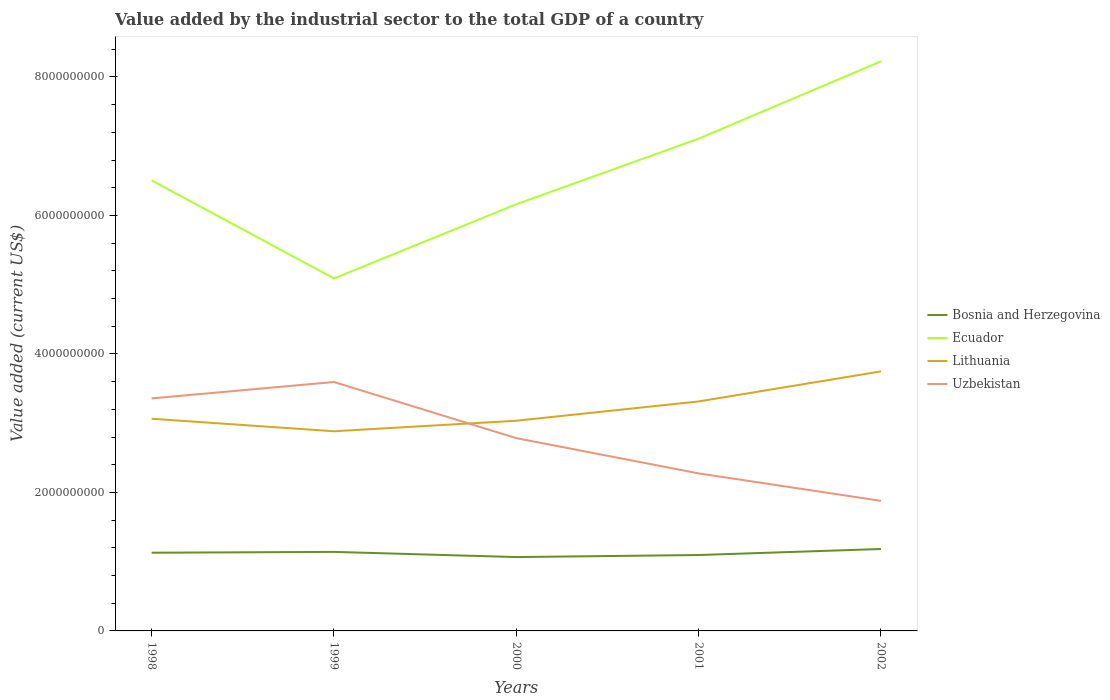How many different coloured lines are there?
Offer a very short reply. 4. Is the number of lines equal to the number of legend labels?
Offer a terse response. Yes. Across all years, what is the maximum value added by the industrial sector to the total GDP in Ecuador?
Keep it short and to the point. 5.09e+09. In which year was the value added by the industrial sector to the total GDP in Ecuador maximum?
Provide a short and direct response. 1999. What is the total value added by the industrial sector to the total GDP in Ecuador in the graph?
Provide a short and direct response. -6.03e+08. What is the difference between the highest and the second highest value added by the industrial sector to the total GDP in Lithuania?
Provide a succinct answer. 8.65e+08. Is the value added by the industrial sector to the total GDP in Lithuania strictly greater than the value added by the industrial sector to the total GDP in Ecuador over the years?
Offer a very short reply. Yes. How many lines are there?
Provide a succinct answer. 4. How many years are there in the graph?
Your answer should be compact. 5. What is the difference between two consecutive major ticks on the Y-axis?
Your answer should be very brief. 2.00e+09. Does the graph contain grids?
Give a very brief answer. No. What is the title of the graph?
Your answer should be very brief. Value added by the industrial sector to the total GDP of a country. What is the label or title of the Y-axis?
Give a very brief answer. Value added (current US$). What is the Value added (current US$) of Bosnia and Herzegovina in 1998?
Provide a short and direct response. 1.13e+09. What is the Value added (current US$) of Ecuador in 1998?
Provide a succinct answer. 6.51e+09. What is the Value added (current US$) in Lithuania in 1998?
Offer a terse response. 3.06e+09. What is the Value added (current US$) in Uzbekistan in 1998?
Offer a very short reply. 3.36e+09. What is the Value added (current US$) in Bosnia and Herzegovina in 1999?
Make the answer very short. 1.14e+09. What is the Value added (current US$) in Ecuador in 1999?
Provide a short and direct response. 5.09e+09. What is the Value added (current US$) in Lithuania in 1999?
Your response must be concise. 2.88e+09. What is the Value added (current US$) in Uzbekistan in 1999?
Keep it short and to the point. 3.59e+09. What is the Value added (current US$) in Bosnia and Herzegovina in 2000?
Your answer should be very brief. 1.07e+09. What is the Value added (current US$) in Ecuador in 2000?
Provide a short and direct response. 6.16e+09. What is the Value added (current US$) in Lithuania in 2000?
Ensure brevity in your answer.  3.04e+09. What is the Value added (current US$) of Uzbekistan in 2000?
Your answer should be very brief. 2.78e+09. What is the Value added (current US$) in Bosnia and Herzegovina in 2001?
Your answer should be very brief. 1.10e+09. What is the Value added (current US$) of Ecuador in 2001?
Offer a terse response. 7.11e+09. What is the Value added (current US$) of Lithuania in 2001?
Ensure brevity in your answer.  3.31e+09. What is the Value added (current US$) in Uzbekistan in 2001?
Give a very brief answer. 2.27e+09. What is the Value added (current US$) of Bosnia and Herzegovina in 2002?
Ensure brevity in your answer.  1.18e+09. What is the Value added (current US$) of Ecuador in 2002?
Provide a short and direct response. 8.22e+09. What is the Value added (current US$) in Lithuania in 2002?
Provide a short and direct response. 3.75e+09. What is the Value added (current US$) of Uzbekistan in 2002?
Make the answer very short. 1.88e+09. Across all years, what is the maximum Value added (current US$) of Bosnia and Herzegovina?
Give a very brief answer. 1.18e+09. Across all years, what is the maximum Value added (current US$) of Ecuador?
Your answer should be very brief. 8.22e+09. Across all years, what is the maximum Value added (current US$) in Lithuania?
Your answer should be compact. 3.75e+09. Across all years, what is the maximum Value added (current US$) of Uzbekistan?
Give a very brief answer. 3.59e+09. Across all years, what is the minimum Value added (current US$) of Bosnia and Herzegovina?
Your response must be concise. 1.07e+09. Across all years, what is the minimum Value added (current US$) of Ecuador?
Offer a very short reply. 5.09e+09. Across all years, what is the minimum Value added (current US$) of Lithuania?
Your answer should be very brief. 2.88e+09. Across all years, what is the minimum Value added (current US$) in Uzbekistan?
Provide a short and direct response. 1.88e+09. What is the total Value added (current US$) in Bosnia and Herzegovina in the graph?
Give a very brief answer. 5.62e+09. What is the total Value added (current US$) in Ecuador in the graph?
Provide a short and direct response. 3.31e+1. What is the total Value added (current US$) in Lithuania in the graph?
Ensure brevity in your answer.  1.60e+1. What is the total Value added (current US$) of Uzbekistan in the graph?
Give a very brief answer. 1.39e+1. What is the difference between the Value added (current US$) of Bosnia and Herzegovina in 1998 and that in 1999?
Your response must be concise. -1.21e+07. What is the difference between the Value added (current US$) in Ecuador in 1998 and that in 1999?
Your response must be concise. 1.42e+09. What is the difference between the Value added (current US$) of Lithuania in 1998 and that in 1999?
Your answer should be compact. 1.81e+08. What is the difference between the Value added (current US$) of Uzbekistan in 1998 and that in 1999?
Provide a short and direct response. -2.37e+08. What is the difference between the Value added (current US$) in Bosnia and Herzegovina in 1998 and that in 2000?
Provide a succinct answer. 6.27e+07. What is the difference between the Value added (current US$) of Ecuador in 1998 and that in 2000?
Offer a terse response. 3.44e+08. What is the difference between the Value added (current US$) of Lithuania in 1998 and that in 2000?
Provide a short and direct response. 2.88e+07. What is the difference between the Value added (current US$) in Uzbekistan in 1998 and that in 2000?
Offer a very short reply. 5.74e+08. What is the difference between the Value added (current US$) of Bosnia and Herzegovina in 1998 and that in 2001?
Offer a terse response. 3.31e+07. What is the difference between the Value added (current US$) of Ecuador in 1998 and that in 2001?
Your answer should be very brief. -6.03e+08. What is the difference between the Value added (current US$) of Lithuania in 1998 and that in 2001?
Provide a short and direct response. -2.49e+08. What is the difference between the Value added (current US$) of Uzbekistan in 1998 and that in 2001?
Offer a very short reply. 1.08e+09. What is the difference between the Value added (current US$) of Bosnia and Herzegovina in 1998 and that in 2002?
Your answer should be very brief. -5.34e+07. What is the difference between the Value added (current US$) of Ecuador in 1998 and that in 2002?
Your answer should be very brief. -1.72e+09. What is the difference between the Value added (current US$) of Lithuania in 1998 and that in 2002?
Keep it short and to the point. -6.84e+08. What is the difference between the Value added (current US$) of Uzbekistan in 1998 and that in 2002?
Your answer should be compact. 1.48e+09. What is the difference between the Value added (current US$) of Bosnia and Herzegovina in 1999 and that in 2000?
Offer a terse response. 7.48e+07. What is the difference between the Value added (current US$) in Ecuador in 1999 and that in 2000?
Your answer should be very brief. -1.07e+09. What is the difference between the Value added (current US$) of Lithuania in 1999 and that in 2000?
Your answer should be very brief. -1.52e+08. What is the difference between the Value added (current US$) of Uzbekistan in 1999 and that in 2000?
Ensure brevity in your answer.  8.11e+08. What is the difference between the Value added (current US$) of Bosnia and Herzegovina in 1999 and that in 2001?
Ensure brevity in your answer.  4.52e+07. What is the difference between the Value added (current US$) in Ecuador in 1999 and that in 2001?
Make the answer very short. -2.02e+09. What is the difference between the Value added (current US$) of Lithuania in 1999 and that in 2001?
Ensure brevity in your answer.  -4.30e+08. What is the difference between the Value added (current US$) of Uzbekistan in 1999 and that in 2001?
Offer a very short reply. 1.32e+09. What is the difference between the Value added (current US$) in Bosnia and Herzegovina in 1999 and that in 2002?
Keep it short and to the point. -4.13e+07. What is the difference between the Value added (current US$) of Ecuador in 1999 and that in 2002?
Ensure brevity in your answer.  -3.13e+09. What is the difference between the Value added (current US$) in Lithuania in 1999 and that in 2002?
Provide a succinct answer. -8.65e+08. What is the difference between the Value added (current US$) of Uzbekistan in 1999 and that in 2002?
Make the answer very short. 1.72e+09. What is the difference between the Value added (current US$) in Bosnia and Herzegovina in 2000 and that in 2001?
Keep it short and to the point. -2.96e+07. What is the difference between the Value added (current US$) in Ecuador in 2000 and that in 2001?
Provide a short and direct response. -9.47e+08. What is the difference between the Value added (current US$) of Lithuania in 2000 and that in 2001?
Ensure brevity in your answer.  -2.78e+08. What is the difference between the Value added (current US$) of Uzbekistan in 2000 and that in 2001?
Ensure brevity in your answer.  5.09e+08. What is the difference between the Value added (current US$) in Bosnia and Herzegovina in 2000 and that in 2002?
Provide a short and direct response. -1.16e+08. What is the difference between the Value added (current US$) of Ecuador in 2000 and that in 2002?
Your answer should be compact. -2.06e+09. What is the difference between the Value added (current US$) of Lithuania in 2000 and that in 2002?
Your answer should be very brief. -7.13e+08. What is the difference between the Value added (current US$) in Uzbekistan in 2000 and that in 2002?
Your answer should be very brief. 9.05e+08. What is the difference between the Value added (current US$) of Bosnia and Herzegovina in 2001 and that in 2002?
Offer a very short reply. -8.65e+07. What is the difference between the Value added (current US$) of Ecuador in 2001 and that in 2002?
Your answer should be very brief. -1.12e+09. What is the difference between the Value added (current US$) in Lithuania in 2001 and that in 2002?
Offer a terse response. -4.34e+08. What is the difference between the Value added (current US$) in Uzbekistan in 2001 and that in 2002?
Make the answer very short. 3.97e+08. What is the difference between the Value added (current US$) in Bosnia and Herzegovina in 1998 and the Value added (current US$) in Ecuador in 1999?
Keep it short and to the point. -3.96e+09. What is the difference between the Value added (current US$) of Bosnia and Herzegovina in 1998 and the Value added (current US$) of Lithuania in 1999?
Your response must be concise. -1.75e+09. What is the difference between the Value added (current US$) of Bosnia and Herzegovina in 1998 and the Value added (current US$) of Uzbekistan in 1999?
Your answer should be compact. -2.47e+09. What is the difference between the Value added (current US$) of Ecuador in 1998 and the Value added (current US$) of Lithuania in 1999?
Offer a very short reply. 3.62e+09. What is the difference between the Value added (current US$) of Ecuador in 1998 and the Value added (current US$) of Uzbekistan in 1999?
Provide a succinct answer. 2.91e+09. What is the difference between the Value added (current US$) in Lithuania in 1998 and the Value added (current US$) in Uzbekistan in 1999?
Offer a terse response. -5.30e+08. What is the difference between the Value added (current US$) in Bosnia and Herzegovina in 1998 and the Value added (current US$) in Ecuador in 2000?
Your answer should be very brief. -5.03e+09. What is the difference between the Value added (current US$) in Bosnia and Herzegovina in 1998 and the Value added (current US$) in Lithuania in 2000?
Keep it short and to the point. -1.91e+09. What is the difference between the Value added (current US$) in Bosnia and Herzegovina in 1998 and the Value added (current US$) in Uzbekistan in 2000?
Provide a short and direct response. -1.65e+09. What is the difference between the Value added (current US$) in Ecuador in 1998 and the Value added (current US$) in Lithuania in 2000?
Offer a very short reply. 3.47e+09. What is the difference between the Value added (current US$) of Ecuador in 1998 and the Value added (current US$) of Uzbekistan in 2000?
Offer a terse response. 3.72e+09. What is the difference between the Value added (current US$) in Lithuania in 1998 and the Value added (current US$) in Uzbekistan in 2000?
Your answer should be compact. 2.80e+08. What is the difference between the Value added (current US$) in Bosnia and Herzegovina in 1998 and the Value added (current US$) in Ecuador in 2001?
Provide a succinct answer. -5.98e+09. What is the difference between the Value added (current US$) of Bosnia and Herzegovina in 1998 and the Value added (current US$) of Lithuania in 2001?
Offer a terse response. -2.18e+09. What is the difference between the Value added (current US$) of Bosnia and Herzegovina in 1998 and the Value added (current US$) of Uzbekistan in 2001?
Give a very brief answer. -1.15e+09. What is the difference between the Value added (current US$) of Ecuador in 1998 and the Value added (current US$) of Lithuania in 2001?
Give a very brief answer. 3.19e+09. What is the difference between the Value added (current US$) of Ecuador in 1998 and the Value added (current US$) of Uzbekistan in 2001?
Your response must be concise. 4.23e+09. What is the difference between the Value added (current US$) of Lithuania in 1998 and the Value added (current US$) of Uzbekistan in 2001?
Your response must be concise. 7.89e+08. What is the difference between the Value added (current US$) in Bosnia and Herzegovina in 1998 and the Value added (current US$) in Ecuador in 2002?
Your answer should be compact. -7.10e+09. What is the difference between the Value added (current US$) in Bosnia and Herzegovina in 1998 and the Value added (current US$) in Lithuania in 2002?
Your response must be concise. -2.62e+09. What is the difference between the Value added (current US$) of Bosnia and Herzegovina in 1998 and the Value added (current US$) of Uzbekistan in 2002?
Keep it short and to the point. -7.49e+08. What is the difference between the Value added (current US$) of Ecuador in 1998 and the Value added (current US$) of Lithuania in 2002?
Give a very brief answer. 2.76e+09. What is the difference between the Value added (current US$) of Ecuador in 1998 and the Value added (current US$) of Uzbekistan in 2002?
Offer a very short reply. 4.63e+09. What is the difference between the Value added (current US$) in Lithuania in 1998 and the Value added (current US$) in Uzbekistan in 2002?
Your response must be concise. 1.19e+09. What is the difference between the Value added (current US$) of Bosnia and Herzegovina in 1999 and the Value added (current US$) of Ecuador in 2000?
Your response must be concise. -5.02e+09. What is the difference between the Value added (current US$) of Bosnia and Herzegovina in 1999 and the Value added (current US$) of Lithuania in 2000?
Offer a terse response. -1.89e+09. What is the difference between the Value added (current US$) in Bosnia and Herzegovina in 1999 and the Value added (current US$) in Uzbekistan in 2000?
Your answer should be compact. -1.64e+09. What is the difference between the Value added (current US$) in Ecuador in 1999 and the Value added (current US$) in Lithuania in 2000?
Give a very brief answer. 2.05e+09. What is the difference between the Value added (current US$) of Ecuador in 1999 and the Value added (current US$) of Uzbekistan in 2000?
Provide a succinct answer. 2.31e+09. What is the difference between the Value added (current US$) in Lithuania in 1999 and the Value added (current US$) in Uzbekistan in 2000?
Your answer should be compact. 9.94e+07. What is the difference between the Value added (current US$) in Bosnia and Herzegovina in 1999 and the Value added (current US$) in Ecuador in 2001?
Your answer should be compact. -5.97e+09. What is the difference between the Value added (current US$) of Bosnia and Herzegovina in 1999 and the Value added (current US$) of Lithuania in 2001?
Your answer should be very brief. -2.17e+09. What is the difference between the Value added (current US$) in Bosnia and Herzegovina in 1999 and the Value added (current US$) in Uzbekistan in 2001?
Ensure brevity in your answer.  -1.13e+09. What is the difference between the Value added (current US$) of Ecuador in 1999 and the Value added (current US$) of Lithuania in 2001?
Give a very brief answer. 1.78e+09. What is the difference between the Value added (current US$) in Ecuador in 1999 and the Value added (current US$) in Uzbekistan in 2001?
Provide a succinct answer. 2.81e+09. What is the difference between the Value added (current US$) in Lithuania in 1999 and the Value added (current US$) in Uzbekistan in 2001?
Your answer should be compact. 6.08e+08. What is the difference between the Value added (current US$) in Bosnia and Herzegovina in 1999 and the Value added (current US$) in Ecuador in 2002?
Keep it short and to the point. -7.08e+09. What is the difference between the Value added (current US$) in Bosnia and Herzegovina in 1999 and the Value added (current US$) in Lithuania in 2002?
Make the answer very short. -2.61e+09. What is the difference between the Value added (current US$) in Bosnia and Herzegovina in 1999 and the Value added (current US$) in Uzbekistan in 2002?
Your response must be concise. -7.37e+08. What is the difference between the Value added (current US$) of Ecuador in 1999 and the Value added (current US$) of Lithuania in 2002?
Your response must be concise. 1.34e+09. What is the difference between the Value added (current US$) of Ecuador in 1999 and the Value added (current US$) of Uzbekistan in 2002?
Make the answer very short. 3.21e+09. What is the difference between the Value added (current US$) in Lithuania in 1999 and the Value added (current US$) in Uzbekistan in 2002?
Give a very brief answer. 1.00e+09. What is the difference between the Value added (current US$) in Bosnia and Herzegovina in 2000 and the Value added (current US$) in Ecuador in 2001?
Keep it short and to the point. -6.04e+09. What is the difference between the Value added (current US$) of Bosnia and Herzegovina in 2000 and the Value added (current US$) of Lithuania in 2001?
Offer a terse response. -2.25e+09. What is the difference between the Value added (current US$) of Bosnia and Herzegovina in 2000 and the Value added (current US$) of Uzbekistan in 2001?
Provide a short and direct response. -1.21e+09. What is the difference between the Value added (current US$) of Ecuador in 2000 and the Value added (current US$) of Lithuania in 2001?
Ensure brevity in your answer.  2.85e+09. What is the difference between the Value added (current US$) of Ecuador in 2000 and the Value added (current US$) of Uzbekistan in 2001?
Your response must be concise. 3.89e+09. What is the difference between the Value added (current US$) in Lithuania in 2000 and the Value added (current US$) in Uzbekistan in 2001?
Offer a very short reply. 7.60e+08. What is the difference between the Value added (current US$) in Bosnia and Herzegovina in 2000 and the Value added (current US$) in Ecuador in 2002?
Provide a short and direct response. -7.16e+09. What is the difference between the Value added (current US$) of Bosnia and Herzegovina in 2000 and the Value added (current US$) of Lithuania in 2002?
Ensure brevity in your answer.  -2.68e+09. What is the difference between the Value added (current US$) in Bosnia and Herzegovina in 2000 and the Value added (current US$) in Uzbekistan in 2002?
Your answer should be very brief. -8.12e+08. What is the difference between the Value added (current US$) of Ecuador in 2000 and the Value added (current US$) of Lithuania in 2002?
Your answer should be compact. 2.41e+09. What is the difference between the Value added (current US$) in Ecuador in 2000 and the Value added (current US$) in Uzbekistan in 2002?
Ensure brevity in your answer.  4.28e+09. What is the difference between the Value added (current US$) of Lithuania in 2000 and the Value added (current US$) of Uzbekistan in 2002?
Give a very brief answer. 1.16e+09. What is the difference between the Value added (current US$) of Bosnia and Herzegovina in 2001 and the Value added (current US$) of Ecuador in 2002?
Keep it short and to the point. -7.13e+09. What is the difference between the Value added (current US$) of Bosnia and Herzegovina in 2001 and the Value added (current US$) of Lithuania in 2002?
Provide a succinct answer. -2.65e+09. What is the difference between the Value added (current US$) in Bosnia and Herzegovina in 2001 and the Value added (current US$) in Uzbekistan in 2002?
Provide a succinct answer. -7.82e+08. What is the difference between the Value added (current US$) of Ecuador in 2001 and the Value added (current US$) of Lithuania in 2002?
Your answer should be very brief. 3.36e+09. What is the difference between the Value added (current US$) in Ecuador in 2001 and the Value added (current US$) in Uzbekistan in 2002?
Give a very brief answer. 5.23e+09. What is the difference between the Value added (current US$) of Lithuania in 2001 and the Value added (current US$) of Uzbekistan in 2002?
Provide a short and direct response. 1.44e+09. What is the average Value added (current US$) in Bosnia and Herzegovina per year?
Keep it short and to the point. 1.12e+09. What is the average Value added (current US$) in Ecuador per year?
Provide a short and direct response. 6.62e+09. What is the average Value added (current US$) in Lithuania per year?
Your response must be concise. 3.21e+09. What is the average Value added (current US$) of Uzbekistan per year?
Your answer should be compact. 2.78e+09. In the year 1998, what is the difference between the Value added (current US$) in Bosnia and Herzegovina and Value added (current US$) in Ecuador?
Offer a very short reply. -5.38e+09. In the year 1998, what is the difference between the Value added (current US$) in Bosnia and Herzegovina and Value added (current US$) in Lithuania?
Keep it short and to the point. -1.93e+09. In the year 1998, what is the difference between the Value added (current US$) in Bosnia and Herzegovina and Value added (current US$) in Uzbekistan?
Ensure brevity in your answer.  -2.23e+09. In the year 1998, what is the difference between the Value added (current US$) of Ecuador and Value added (current US$) of Lithuania?
Offer a terse response. 3.44e+09. In the year 1998, what is the difference between the Value added (current US$) of Ecuador and Value added (current US$) of Uzbekistan?
Make the answer very short. 3.15e+09. In the year 1998, what is the difference between the Value added (current US$) in Lithuania and Value added (current US$) in Uzbekistan?
Your response must be concise. -2.94e+08. In the year 1999, what is the difference between the Value added (current US$) in Bosnia and Herzegovina and Value added (current US$) in Ecuador?
Keep it short and to the point. -3.95e+09. In the year 1999, what is the difference between the Value added (current US$) of Bosnia and Herzegovina and Value added (current US$) of Lithuania?
Offer a terse response. -1.74e+09. In the year 1999, what is the difference between the Value added (current US$) in Bosnia and Herzegovina and Value added (current US$) in Uzbekistan?
Keep it short and to the point. -2.45e+09. In the year 1999, what is the difference between the Value added (current US$) of Ecuador and Value added (current US$) of Lithuania?
Give a very brief answer. 2.21e+09. In the year 1999, what is the difference between the Value added (current US$) in Ecuador and Value added (current US$) in Uzbekistan?
Keep it short and to the point. 1.50e+09. In the year 1999, what is the difference between the Value added (current US$) in Lithuania and Value added (current US$) in Uzbekistan?
Provide a short and direct response. -7.11e+08. In the year 2000, what is the difference between the Value added (current US$) of Bosnia and Herzegovina and Value added (current US$) of Ecuador?
Your answer should be very brief. -5.09e+09. In the year 2000, what is the difference between the Value added (current US$) of Bosnia and Herzegovina and Value added (current US$) of Lithuania?
Ensure brevity in your answer.  -1.97e+09. In the year 2000, what is the difference between the Value added (current US$) in Bosnia and Herzegovina and Value added (current US$) in Uzbekistan?
Provide a succinct answer. -1.72e+09. In the year 2000, what is the difference between the Value added (current US$) of Ecuador and Value added (current US$) of Lithuania?
Provide a short and direct response. 3.13e+09. In the year 2000, what is the difference between the Value added (current US$) in Ecuador and Value added (current US$) in Uzbekistan?
Keep it short and to the point. 3.38e+09. In the year 2000, what is the difference between the Value added (current US$) in Lithuania and Value added (current US$) in Uzbekistan?
Keep it short and to the point. 2.51e+08. In the year 2001, what is the difference between the Value added (current US$) in Bosnia and Herzegovina and Value added (current US$) in Ecuador?
Keep it short and to the point. -6.01e+09. In the year 2001, what is the difference between the Value added (current US$) of Bosnia and Herzegovina and Value added (current US$) of Lithuania?
Provide a succinct answer. -2.22e+09. In the year 2001, what is the difference between the Value added (current US$) of Bosnia and Herzegovina and Value added (current US$) of Uzbekistan?
Provide a short and direct response. -1.18e+09. In the year 2001, what is the difference between the Value added (current US$) in Ecuador and Value added (current US$) in Lithuania?
Provide a short and direct response. 3.79e+09. In the year 2001, what is the difference between the Value added (current US$) of Ecuador and Value added (current US$) of Uzbekistan?
Offer a very short reply. 4.83e+09. In the year 2001, what is the difference between the Value added (current US$) in Lithuania and Value added (current US$) in Uzbekistan?
Provide a succinct answer. 1.04e+09. In the year 2002, what is the difference between the Value added (current US$) of Bosnia and Herzegovina and Value added (current US$) of Ecuador?
Your answer should be very brief. -7.04e+09. In the year 2002, what is the difference between the Value added (current US$) of Bosnia and Herzegovina and Value added (current US$) of Lithuania?
Offer a very short reply. -2.57e+09. In the year 2002, what is the difference between the Value added (current US$) in Bosnia and Herzegovina and Value added (current US$) in Uzbekistan?
Offer a terse response. -6.96e+08. In the year 2002, what is the difference between the Value added (current US$) in Ecuador and Value added (current US$) in Lithuania?
Your answer should be compact. 4.48e+09. In the year 2002, what is the difference between the Value added (current US$) of Ecuador and Value added (current US$) of Uzbekistan?
Offer a very short reply. 6.35e+09. In the year 2002, what is the difference between the Value added (current US$) of Lithuania and Value added (current US$) of Uzbekistan?
Your response must be concise. 1.87e+09. What is the ratio of the Value added (current US$) in Ecuador in 1998 to that in 1999?
Your answer should be very brief. 1.28. What is the ratio of the Value added (current US$) in Lithuania in 1998 to that in 1999?
Offer a terse response. 1.06. What is the ratio of the Value added (current US$) in Uzbekistan in 1998 to that in 1999?
Provide a succinct answer. 0.93. What is the ratio of the Value added (current US$) of Bosnia and Herzegovina in 1998 to that in 2000?
Offer a terse response. 1.06. What is the ratio of the Value added (current US$) in Ecuador in 1998 to that in 2000?
Provide a succinct answer. 1.06. What is the ratio of the Value added (current US$) of Lithuania in 1998 to that in 2000?
Ensure brevity in your answer.  1.01. What is the ratio of the Value added (current US$) in Uzbekistan in 1998 to that in 2000?
Ensure brevity in your answer.  1.21. What is the ratio of the Value added (current US$) in Bosnia and Herzegovina in 1998 to that in 2001?
Give a very brief answer. 1.03. What is the ratio of the Value added (current US$) of Ecuador in 1998 to that in 2001?
Keep it short and to the point. 0.92. What is the ratio of the Value added (current US$) of Lithuania in 1998 to that in 2001?
Offer a terse response. 0.92. What is the ratio of the Value added (current US$) of Uzbekistan in 1998 to that in 2001?
Provide a short and direct response. 1.48. What is the ratio of the Value added (current US$) in Bosnia and Herzegovina in 1998 to that in 2002?
Keep it short and to the point. 0.95. What is the ratio of the Value added (current US$) of Ecuador in 1998 to that in 2002?
Provide a short and direct response. 0.79. What is the ratio of the Value added (current US$) of Lithuania in 1998 to that in 2002?
Provide a short and direct response. 0.82. What is the ratio of the Value added (current US$) of Uzbekistan in 1998 to that in 2002?
Offer a very short reply. 1.79. What is the ratio of the Value added (current US$) of Bosnia and Herzegovina in 1999 to that in 2000?
Offer a terse response. 1.07. What is the ratio of the Value added (current US$) of Ecuador in 1999 to that in 2000?
Offer a very short reply. 0.83. What is the ratio of the Value added (current US$) in Lithuania in 1999 to that in 2000?
Ensure brevity in your answer.  0.95. What is the ratio of the Value added (current US$) of Uzbekistan in 1999 to that in 2000?
Your answer should be compact. 1.29. What is the ratio of the Value added (current US$) in Bosnia and Herzegovina in 1999 to that in 2001?
Your answer should be compact. 1.04. What is the ratio of the Value added (current US$) in Ecuador in 1999 to that in 2001?
Offer a very short reply. 0.72. What is the ratio of the Value added (current US$) in Lithuania in 1999 to that in 2001?
Offer a terse response. 0.87. What is the ratio of the Value added (current US$) in Uzbekistan in 1999 to that in 2001?
Your answer should be very brief. 1.58. What is the ratio of the Value added (current US$) of Ecuador in 1999 to that in 2002?
Provide a short and direct response. 0.62. What is the ratio of the Value added (current US$) of Lithuania in 1999 to that in 2002?
Keep it short and to the point. 0.77. What is the ratio of the Value added (current US$) in Uzbekistan in 1999 to that in 2002?
Provide a short and direct response. 1.91. What is the ratio of the Value added (current US$) of Ecuador in 2000 to that in 2001?
Ensure brevity in your answer.  0.87. What is the ratio of the Value added (current US$) of Lithuania in 2000 to that in 2001?
Give a very brief answer. 0.92. What is the ratio of the Value added (current US$) of Uzbekistan in 2000 to that in 2001?
Offer a terse response. 1.22. What is the ratio of the Value added (current US$) of Bosnia and Herzegovina in 2000 to that in 2002?
Your response must be concise. 0.9. What is the ratio of the Value added (current US$) in Ecuador in 2000 to that in 2002?
Make the answer very short. 0.75. What is the ratio of the Value added (current US$) in Lithuania in 2000 to that in 2002?
Your answer should be very brief. 0.81. What is the ratio of the Value added (current US$) of Uzbekistan in 2000 to that in 2002?
Your answer should be very brief. 1.48. What is the ratio of the Value added (current US$) of Bosnia and Herzegovina in 2001 to that in 2002?
Your answer should be compact. 0.93. What is the ratio of the Value added (current US$) in Ecuador in 2001 to that in 2002?
Offer a terse response. 0.86. What is the ratio of the Value added (current US$) in Lithuania in 2001 to that in 2002?
Your response must be concise. 0.88. What is the ratio of the Value added (current US$) of Uzbekistan in 2001 to that in 2002?
Your answer should be compact. 1.21. What is the difference between the highest and the second highest Value added (current US$) in Bosnia and Herzegovina?
Your response must be concise. 4.13e+07. What is the difference between the highest and the second highest Value added (current US$) of Ecuador?
Make the answer very short. 1.12e+09. What is the difference between the highest and the second highest Value added (current US$) in Lithuania?
Give a very brief answer. 4.34e+08. What is the difference between the highest and the second highest Value added (current US$) in Uzbekistan?
Your answer should be compact. 2.37e+08. What is the difference between the highest and the lowest Value added (current US$) in Bosnia and Herzegovina?
Give a very brief answer. 1.16e+08. What is the difference between the highest and the lowest Value added (current US$) of Ecuador?
Provide a short and direct response. 3.13e+09. What is the difference between the highest and the lowest Value added (current US$) in Lithuania?
Give a very brief answer. 8.65e+08. What is the difference between the highest and the lowest Value added (current US$) in Uzbekistan?
Provide a short and direct response. 1.72e+09. 